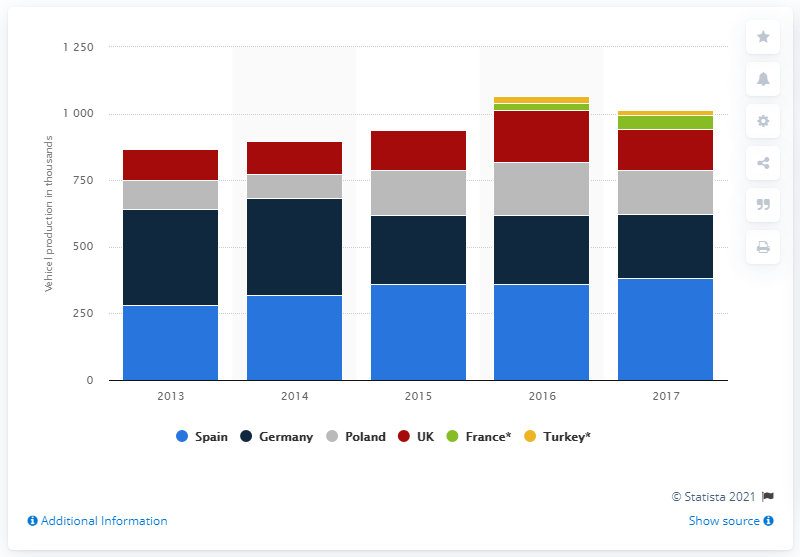Indicate a few pertinent items in this graphic. The peak year in which Opel's European sales reached their highest level was 2016. From 2013 to 2015, the production of vehicles in Spain increased by 28%. In 2017, Germany's vehicle production reached its lowest point. 